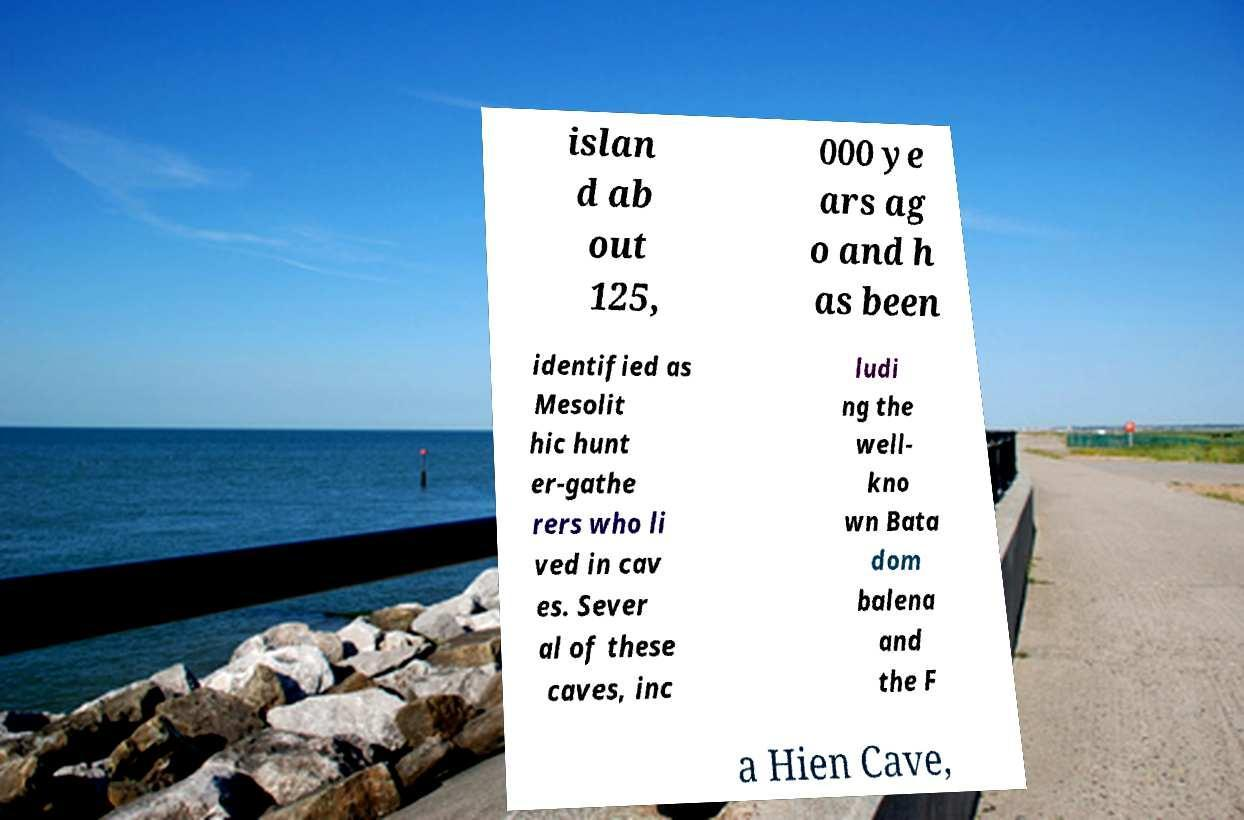For documentation purposes, I need the text within this image transcribed. Could you provide that? islan d ab out 125, 000 ye ars ag o and h as been identified as Mesolit hic hunt er-gathe rers who li ved in cav es. Sever al of these caves, inc ludi ng the well- kno wn Bata dom balena and the F a Hien Cave, 